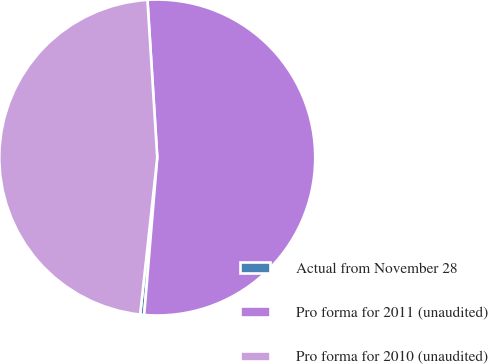Convert chart. <chart><loc_0><loc_0><loc_500><loc_500><pie_chart><fcel>Actual from November 28<fcel>Pro forma for 2011 (unaudited)<fcel>Pro forma for 2010 (unaudited)<nl><fcel>0.41%<fcel>52.31%<fcel>47.28%<nl></chart> 